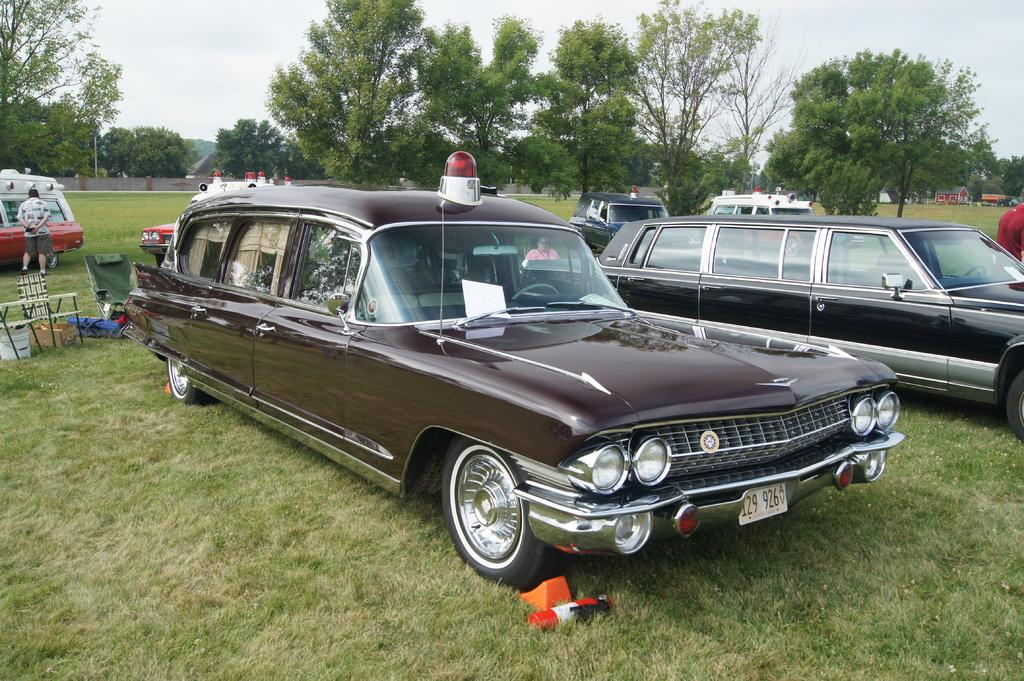What can be seen parked in the image? There are cars parked in the image. What else is visible in the image besides the parked cars? There are people standing in the image. What type of natural scenery is visible in the background of the image? There are trees in the background of the image. How would you describe the sky in the image? The sky is visible at the top of the image and appears to be cloudy. Where is the goat located in the image? There is no goat present in the image. What color is the paint on the crib in the image? There is no crib present in the image. 